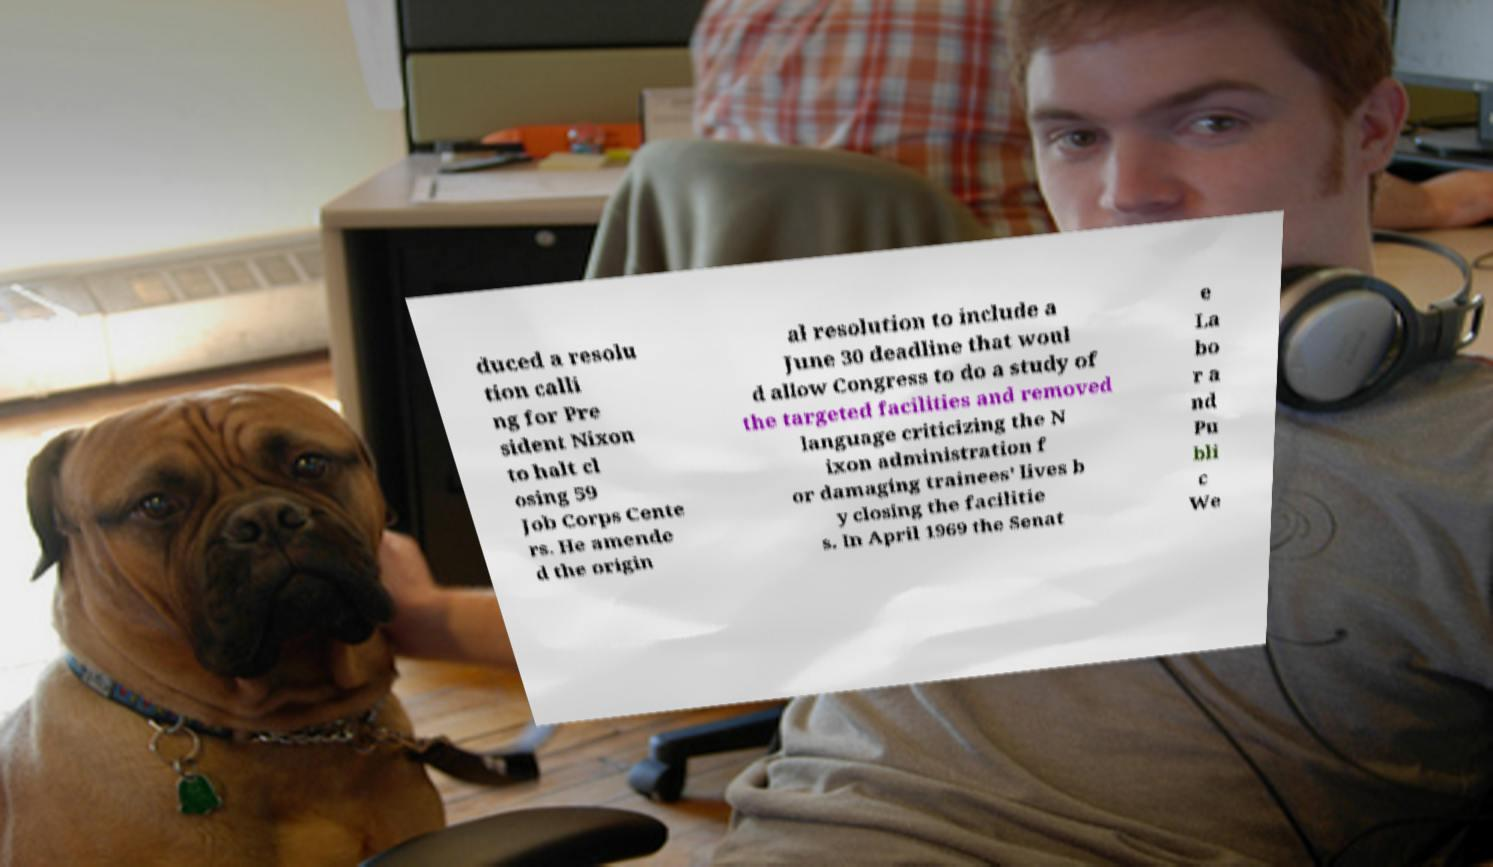What messages or text are displayed in this image? I need them in a readable, typed format. duced a resolu tion calli ng for Pre sident Nixon to halt cl osing 59 Job Corps Cente rs. He amende d the origin al resolution to include a June 30 deadline that woul d allow Congress to do a study of the targeted facilities and removed language criticizing the N ixon administration f or damaging trainees' lives b y closing the facilitie s. In April 1969 the Senat e La bo r a nd Pu bli c We 